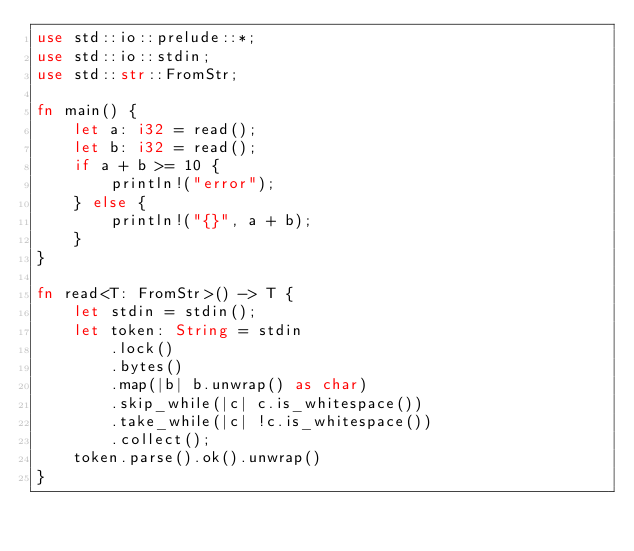Convert code to text. <code><loc_0><loc_0><loc_500><loc_500><_Rust_>use std::io::prelude::*;
use std::io::stdin;
use std::str::FromStr;

fn main() {
    let a: i32 = read();
    let b: i32 = read();
    if a + b >= 10 {
        println!("error");
    } else {
        println!("{}", a + b);
    }
}

fn read<T: FromStr>() -> T {
    let stdin = stdin();
    let token: String = stdin
        .lock()
        .bytes()
        .map(|b| b.unwrap() as char)
        .skip_while(|c| c.is_whitespace())
        .take_while(|c| !c.is_whitespace())
        .collect();
    token.parse().ok().unwrap()
}
</code> 